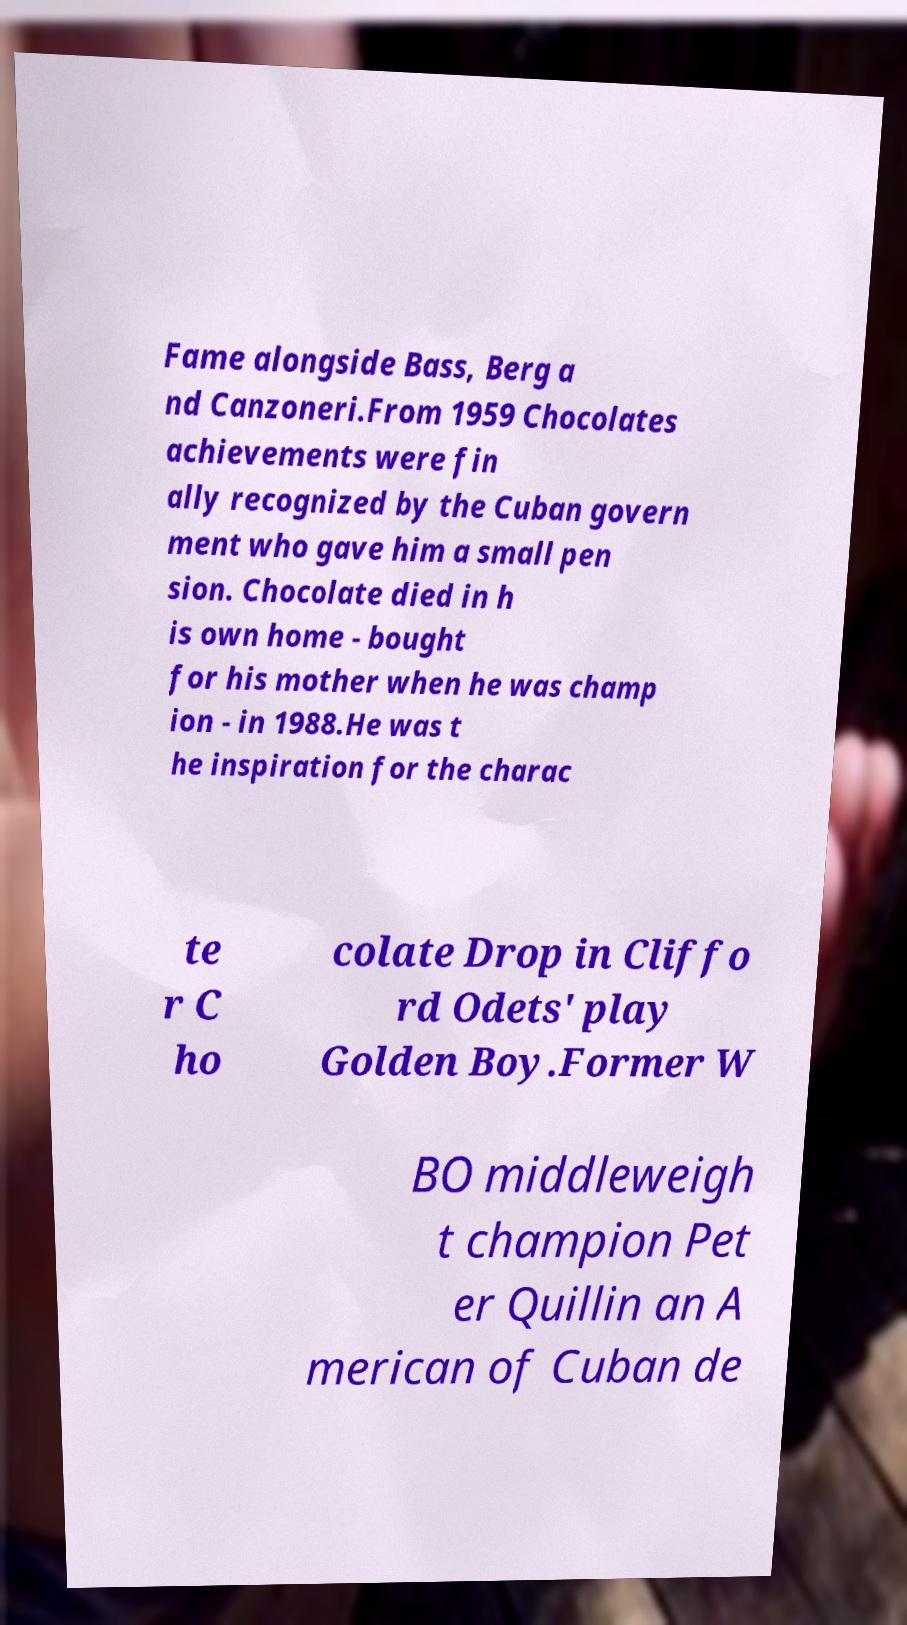What messages or text are displayed in this image? I need them in a readable, typed format. Fame alongside Bass, Berg a nd Canzoneri.From 1959 Chocolates achievements were fin ally recognized by the Cuban govern ment who gave him a small pen sion. Chocolate died in h is own home - bought for his mother when he was champ ion - in 1988.He was t he inspiration for the charac te r C ho colate Drop in Cliffo rd Odets' play Golden Boy.Former W BO middleweigh t champion Pet er Quillin an A merican of Cuban de 